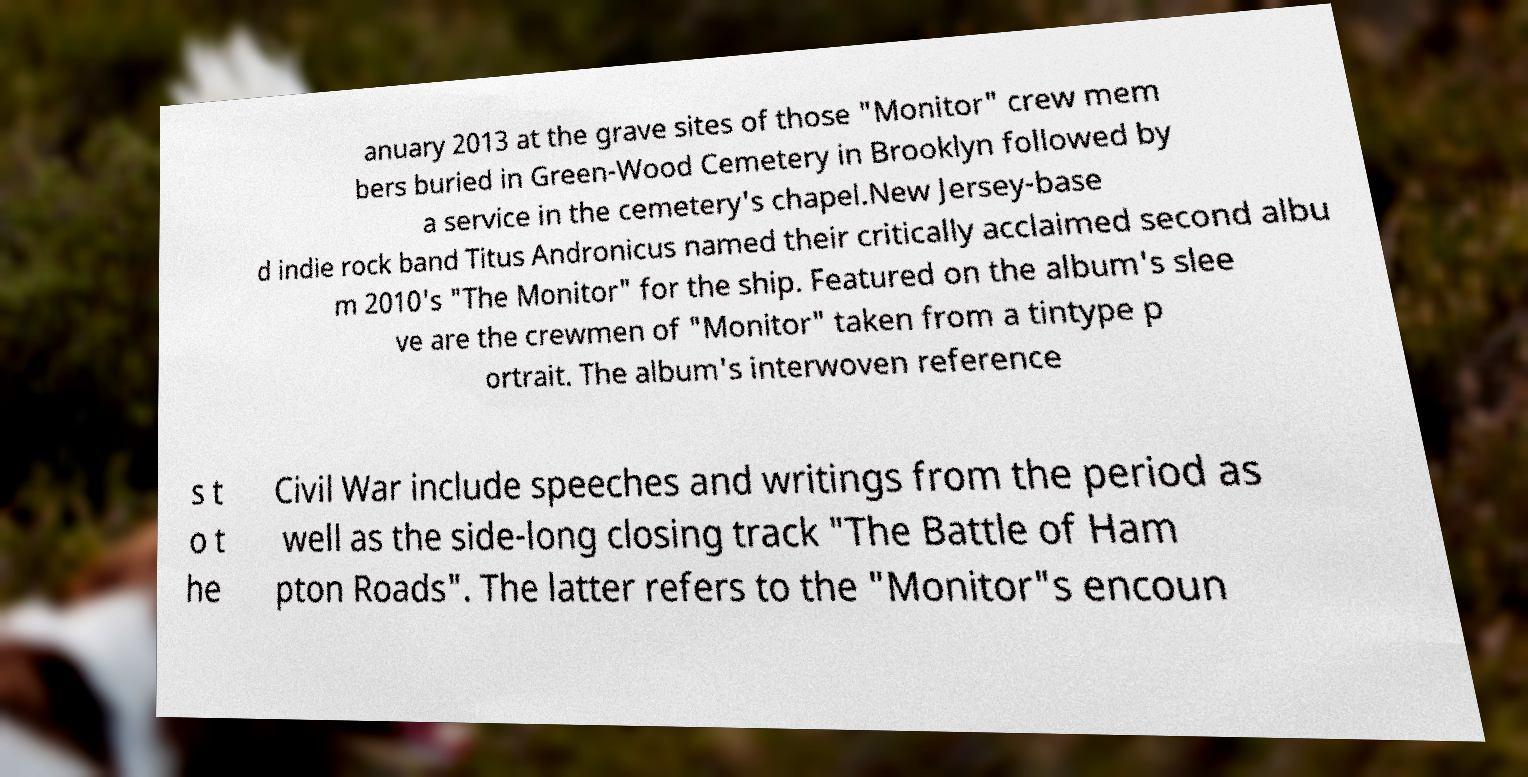Can you accurately transcribe the text from the provided image for me? anuary 2013 at the grave sites of those "Monitor" crew mem bers buried in Green-Wood Cemetery in Brooklyn followed by a service in the cemetery's chapel.New Jersey-base d indie rock band Titus Andronicus named their critically acclaimed second albu m 2010's "The Monitor" for the ship. Featured on the album's slee ve are the crewmen of "Monitor" taken from a tintype p ortrait. The album's interwoven reference s t o t he Civil War include speeches and writings from the period as well as the side-long closing track "The Battle of Ham pton Roads". The latter refers to the "Monitor"s encoun 